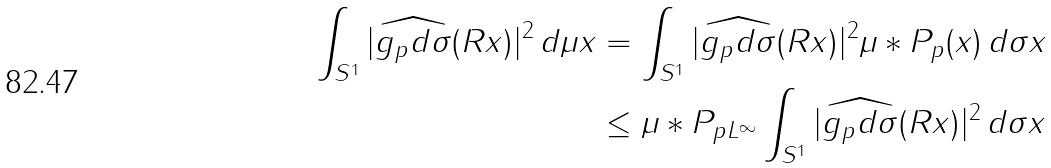Convert formula to latex. <formula><loc_0><loc_0><loc_500><loc_500>\int _ { S ^ { 1 } } | \widehat { g _ { p } d \sigma } ( R x ) | ^ { 2 } \, d \mu x & = \int _ { S ^ { 1 } } | \widehat { g _ { p } d \sigma } ( R x ) | ^ { 2 } \mu \ast P _ { p } ( x ) \, d \sigma x \\ & \leq \| \mu \ast P _ { p } \| _ { L ^ { \infty } } \int _ { S ^ { 1 } } | \widehat { g _ { p } d \sigma } ( R x ) | ^ { 2 } \, d \sigma x</formula> 